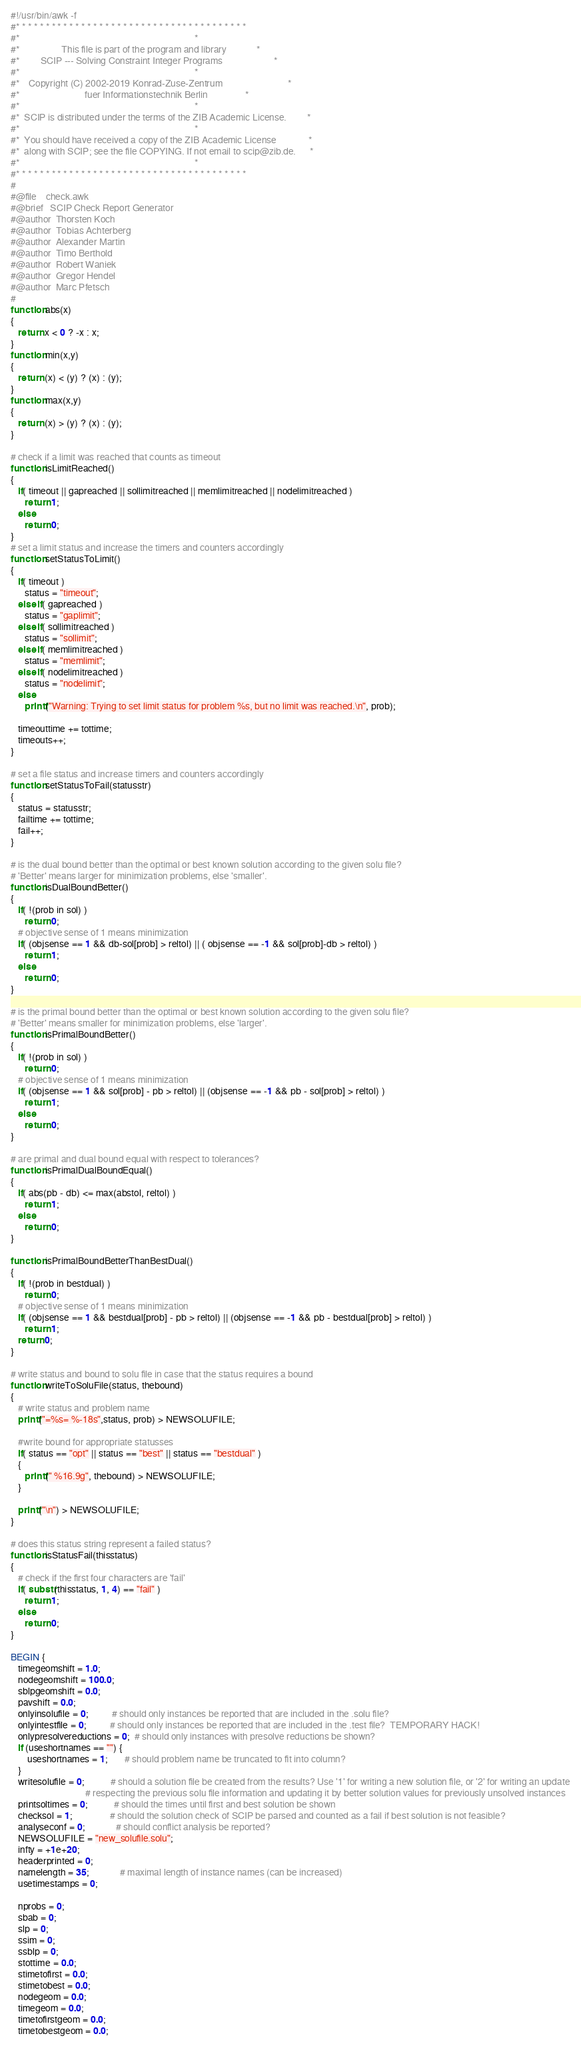Convert code to text. <code><loc_0><loc_0><loc_500><loc_500><_Awk_>#!/usr/bin/awk -f
#* * * * * * * * * * * * * * * * * * * * * * * * * * * * * * * * * * * * * * *
#*                                                                           *
#*                  This file is part of the program and library             *
#*         SCIP --- Solving Constraint Integer Programs                      *
#*                                                                           *
#*    Copyright (C) 2002-2019 Konrad-Zuse-Zentrum                            *
#*                            fuer Informationstechnik Berlin                *
#*                                                                           *
#*  SCIP is distributed under the terms of the ZIB Academic License.         *
#*                                                                           *
#*  You should have received a copy of the ZIB Academic License              *
#*  along with SCIP; see the file COPYING. If not email to scip@zib.de.      *
#*                                                                           *
#* * * * * * * * * * * * * * * * * * * * * * * * * * * * * * * * * * * * * * *
#
#@file    check.awk
#@brief   SCIP Check Report Generator
#@author  Thorsten Koch
#@author  Tobias Achterberg
#@author  Alexander Martin
#@author  Timo Berthold
#@author  Robert Waniek
#@author  Gregor Hendel
#@author  Marc Pfetsch
#
function abs(x)
{
   return x < 0 ? -x : x;
}
function min(x,y)
{
   return (x) < (y) ? (x) : (y);
}
function max(x,y)
{
   return (x) > (y) ? (x) : (y);
}

# check if a limit was reached that counts as timeout
function isLimitReached()
{
   if( timeout || gapreached || sollimitreached || memlimitreached || nodelimitreached )
      return 1;
   else
      return 0;
}
# set a limit status and increase the timers and counters accordingly
function setStatusToLimit()
{
   if( timeout )
      status = "timeout";
   else if( gapreached )
      status = "gaplimit";
   else if( sollimitreached )
      status = "sollimit";
   else if( memlimitreached )
      status = "memlimit";
   else if( nodelimitreached )
      status = "nodelimit";
   else
      printf("Warning: Trying to set limit status for problem %s, but no limit was reached.\n", prob);

   timeouttime += tottime;
   timeouts++;
}

# set a file status and increase timers and counters accordingly
function setStatusToFail(statusstr)
{
   status = statusstr;
   failtime += tottime;
   fail++;
}

# is the dual bound better than the optimal or best known solution according to the given solu file?
# 'Better' means larger for minimization problems, else 'smaller'.
function isDualBoundBetter()
{
   if( !(prob in sol) )
      return 0;
   # objective sense of 1 means minimization
   if( (objsense == 1 && db-sol[prob] > reltol) || ( objsense == -1 && sol[prob]-db > reltol) )
      return 1;
   else
      return 0;
}

# is the primal bound better than the optimal or best known solution according to the given solu file?
# 'Better' means smaller for minimization problems, else 'larger'.
function isPrimalBoundBetter()
{
   if( !(prob in sol) )
      return 0;
   # objective sense of 1 means minimization
   if( (objsense == 1 && sol[prob] - pb > reltol) || (objsense == -1 && pb - sol[prob] > reltol) )
      return 1;
   else
      return 0;
}

# are primal and dual bound equal with respect to tolerances?
function isPrimalDualBoundEqual()
{
   if( abs(pb - db) <= max(abstol, reltol) )
      return 1;
   else
      return 0;
}

function isPrimalBoundBetterThanBestDual()
{
   if( !(prob in bestdual) )
      return 0;
   # objective sense of 1 means minimization
   if( (objsense == 1 && bestdual[prob] - pb > reltol) || (objsense == -1 && pb - bestdual[prob] > reltol) )
      return 1;
   return 0;
}

# write status and bound to solu file in case that the status requires a bound
function writeToSoluFile(status, thebound)
{
   # write status and problem name
   printf("=%s= %-18s",status, prob) > NEWSOLUFILE;

   #write bound for appropriate statusses
   if( status == "opt" || status == "best" || status == "bestdual" )
   {
      printf(" %16.9g", thebound) > NEWSOLUFILE;
   }

   printf("\n") > NEWSOLUFILE;
}

# does this status string represent a failed status?
function isStatusFail(thisstatus)
{
   # check if the first four characters are 'fail'
   if( substr(thisstatus, 1, 4) == "fail" )
      return 1;
   else
      return 0;
}

BEGIN {
   timegeomshift = 1.0;
   nodegeomshift = 100.0;
   sblpgeomshift = 0.0;
   pavshift = 0.0;
   onlyinsolufile = 0;          # should only instances be reported that are included in the .solu file?
   onlyintestfile = 0;          # should only instances be reported that are included in the .test file?  TEMPORARY HACK!
   onlypresolvereductions = 0;  # should only instances with presolve reductions be shown?
   if (useshortnames == "") {
       useshortnames = 1;       # should problem name be truncated to fit into column?
   }
   writesolufile = 0;           # should a solution file be created from the results? Use '1' for writing a new solution file, or '2' for writing an update
                                # respecting the previous solu file information and updating it by better solution values for previously unsolved instances
   printsoltimes = 0;           # should the times until first and best solution be shown
   checksol = 1;                # should the solution check of SCIP be parsed and counted as a fail if best solution is not feasible?
   analyseconf = 0;             # should conflict analysis be reported?
   NEWSOLUFILE = "new_solufile.solu";
   infty = +1e+20;
   headerprinted = 0;
   namelength = 35;             # maximal length of instance names (can be increased)
   usetimestamps = 0;

   nprobs = 0;
   sbab = 0;
   slp = 0;
   ssim = 0;
   ssblp = 0;
   stottime = 0.0;
   stimetofirst = 0.0;
   stimetobest = 0.0;
   nodegeom = 0.0;
   timegeom = 0.0;
   timetofirstgeom = 0.0;
   timetobestgeom = 0.0;</code> 